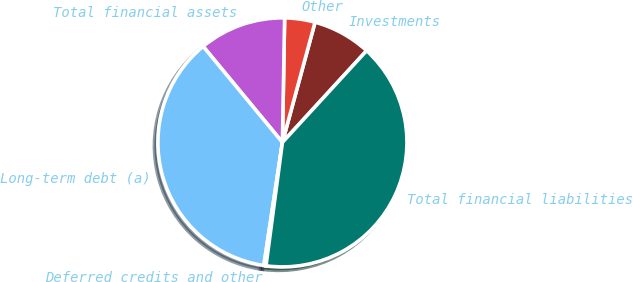Convert chart. <chart><loc_0><loc_0><loc_500><loc_500><pie_chart><fcel>Investments<fcel>Other<fcel>Total financial assets<fcel>Long-term debt (a)<fcel>Deferred credits and other<fcel>Total financial liabilities<nl><fcel>7.6%<fcel>3.94%<fcel>11.27%<fcel>36.62%<fcel>0.28%<fcel>40.28%<nl></chart> 